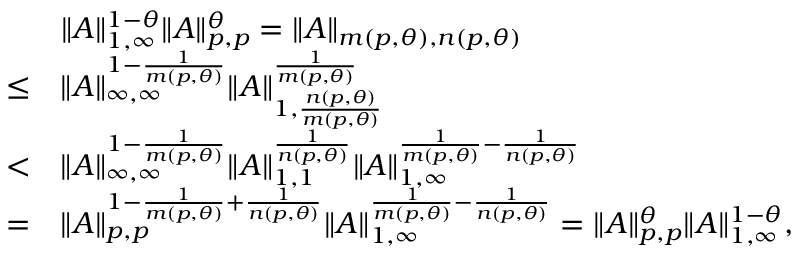Convert formula to latex. <formula><loc_0><loc_0><loc_500><loc_500>\begin{array} { r l } & { \| A \| _ { 1 , \infty } ^ { 1 - \theta } \| A \| _ { p , p } ^ { \theta } = \| A \| _ { m ( p , \theta ) , n ( p , \theta ) } } \\ { \leq } & { \| A \| _ { \infty , \infty } ^ { 1 - \frac { 1 } { m ( p , \theta ) } } \| A \| _ { 1 , \frac { n ( p , \theta ) } { m ( p , \theta ) } } ^ { \frac { 1 } { m ( p , \theta ) } } } \\ { < } & { \| A \| _ { \infty , \infty } ^ { 1 - \frac { 1 } { m ( p , \theta ) } } \| A \| _ { 1 , 1 } ^ { \frac { 1 } { n ( p , \theta ) } } \| A \| _ { 1 , \infty } ^ { \frac { 1 } { m ( p , \theta ) } - \frac { 1 } { n ( p , \theta ) } } } \\ { = } & { \| A \| _ { p , p } ^ { 1 - \frac { 1 } { m ( p , \theta ) } + \frac { 1 } { n ( p , \theta ) } } \| A \| _ { 1 , \infty } ^ { \frac { 1 } { m ( p , \theta ) } - \frac { 1 } { n ( p , \theta ) } } = \| A \| _ { p , p } ^ { \theta } \| A \| _ { 1 , \infty } ^ { 1 - \theta } , } \end{array}</formula> 